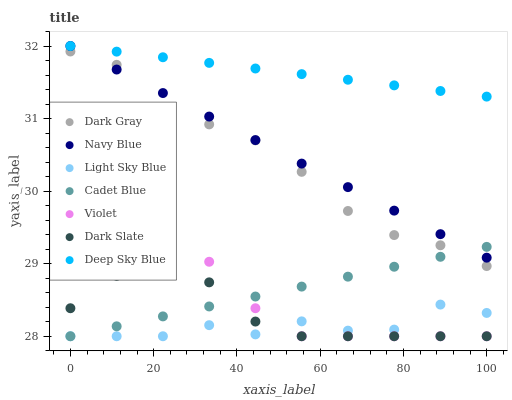Does Light Sky Blue have the minimum area under the curve?
Answer yes or no. Yes. Does Deep Sky Blue have the maximum area under the curve?
Answer yes or no. Yes. Does Navy Blue have the minimum area under the curve?
Answer yes or no. No. Does Navy Blue have the maximum area under the curve?
Answer yes or no. No. Is Cadet Blue the smoothest?
Answer yes or no. Yes. Is Light Sky Blue the roughest?
Answer yes or no. Yes. Is Navy Blue the smoothest?
Answer yes or no. No. Is Navy Blue the roughest?
Answer yes or no. No. Does Cadet Blue have the lowest value?
Answer yes or no. Yes. Does Navy Blue have the lowest value?
Answer yes or no. No. Does Deep Sky Blue have the highest value?
Answer yes or no. Yes. Does Dark Gray have the highest value?
Answer yes or no. No. Is Violet less than Navy Blue?
Answer yes or no. Yes. Is Navy Blue greater than Dark Slate?
Answer yes or no. Yes. Does Light Sky Blue intersect Cadet Blue?
Answer yes or no. Yes. Is Light Sky Blue less than Cadet Blue?
Answer yes or no. No. Is Light Sky Blue greater than Cadet Blue?
Answer yes or no. No. Does Violet intersect Navy Blue?
Answer yes or no. No. 